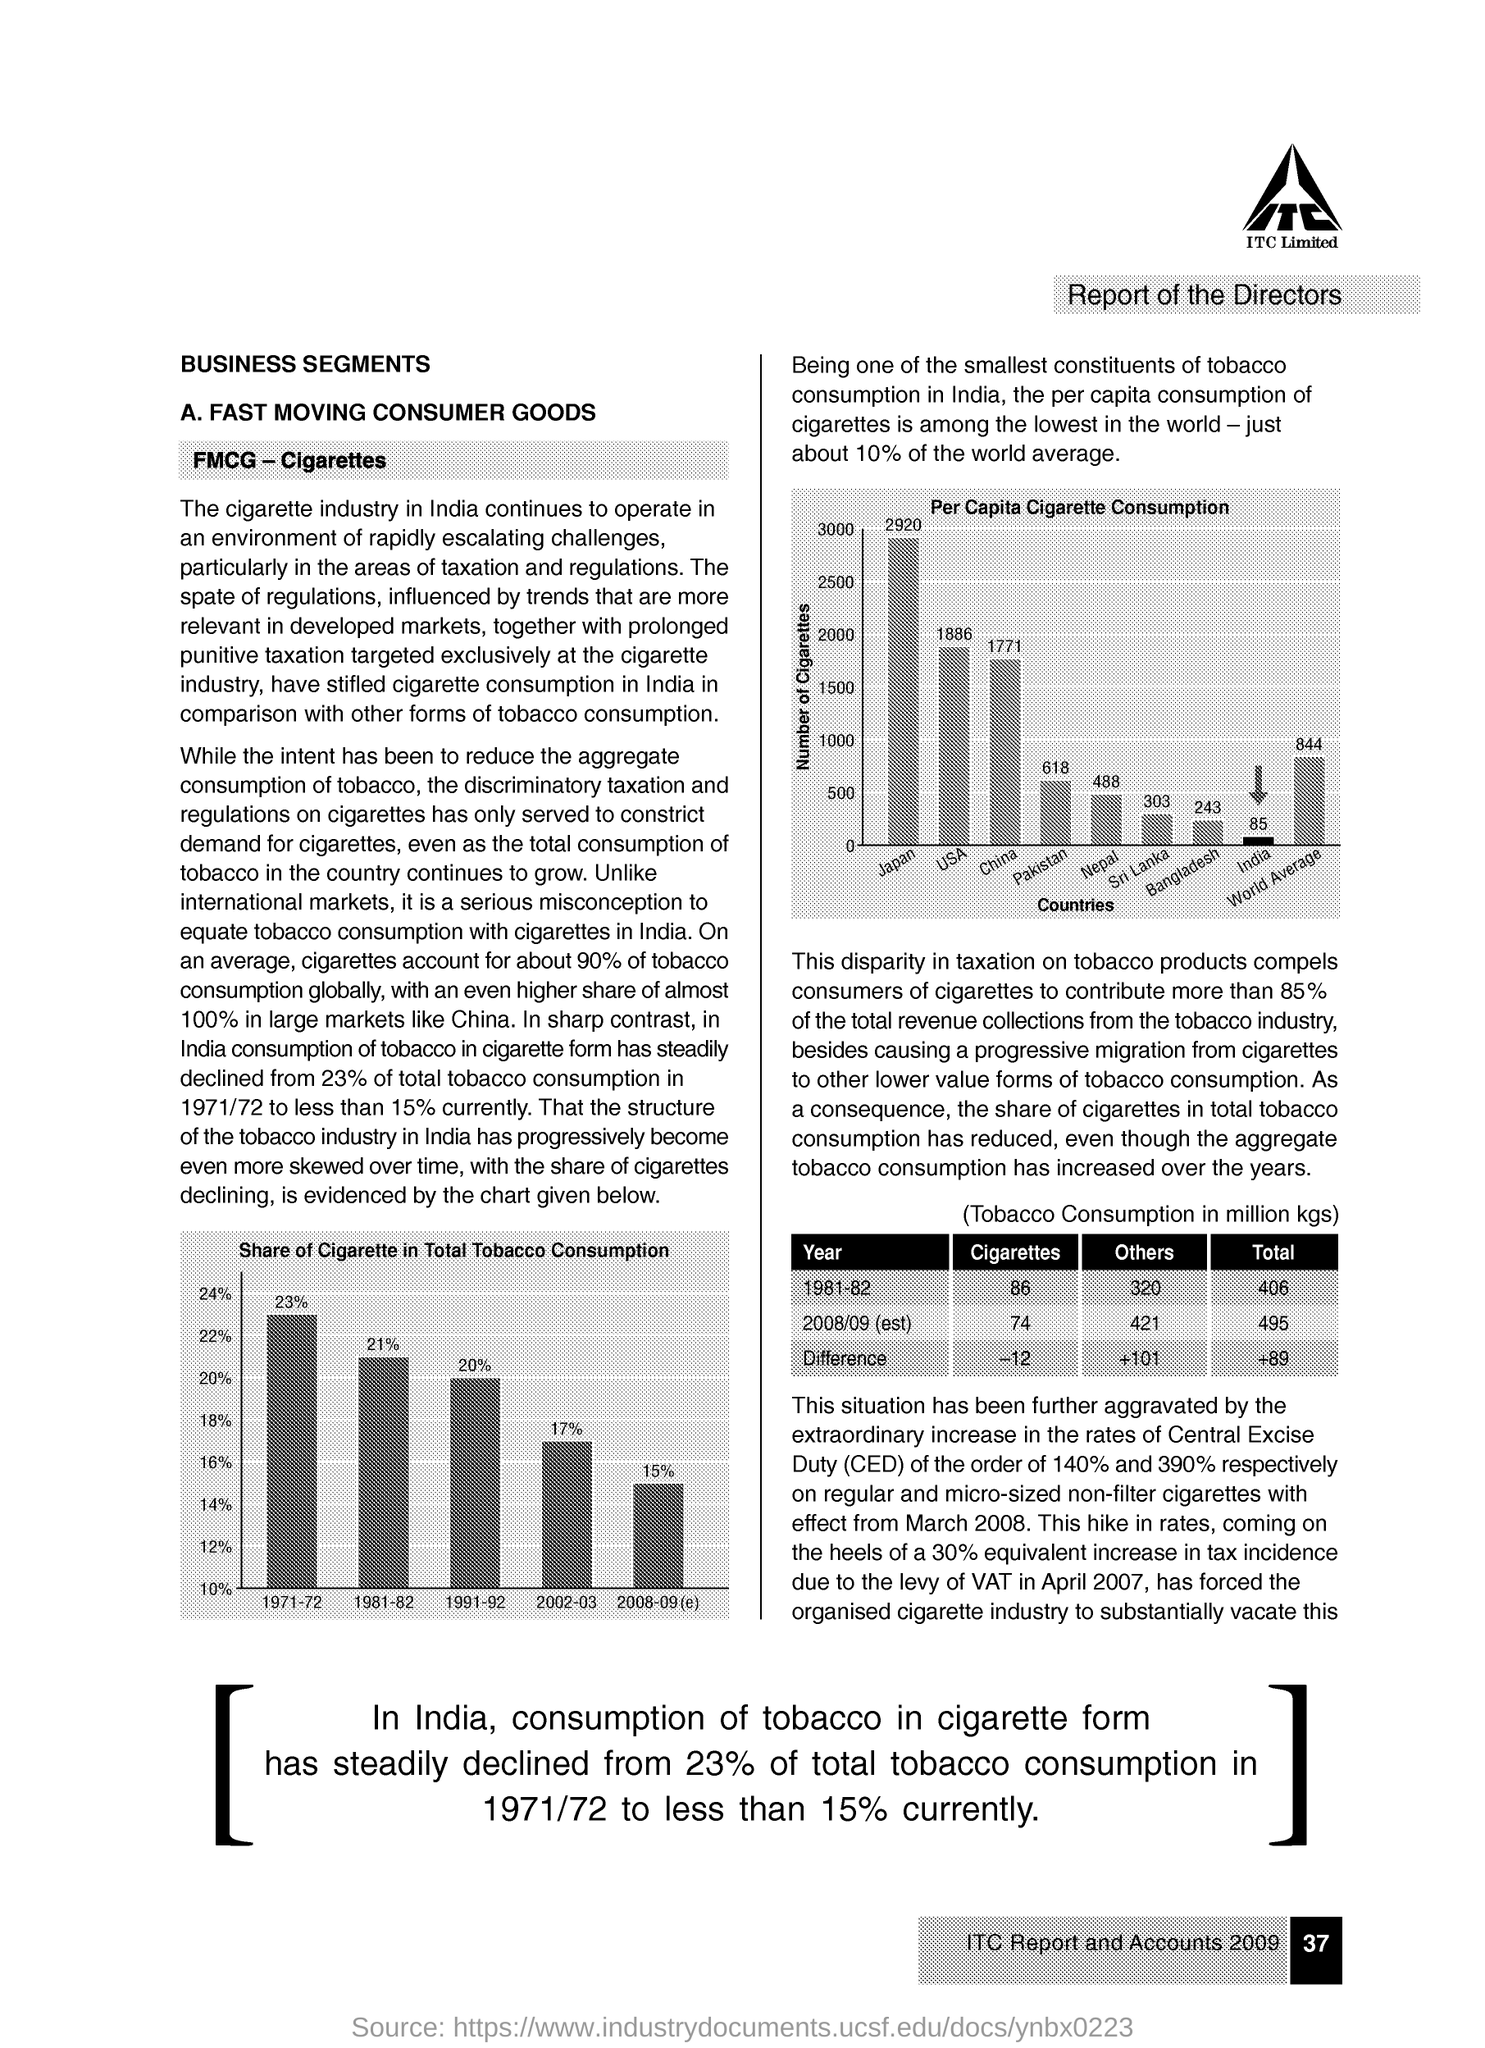What is per capita cigarette consumption from the china ?
Offer a terse response. 1771. What is per capita cigarette consumption from the country called pakistan?
Your answer should be compact. 618. 